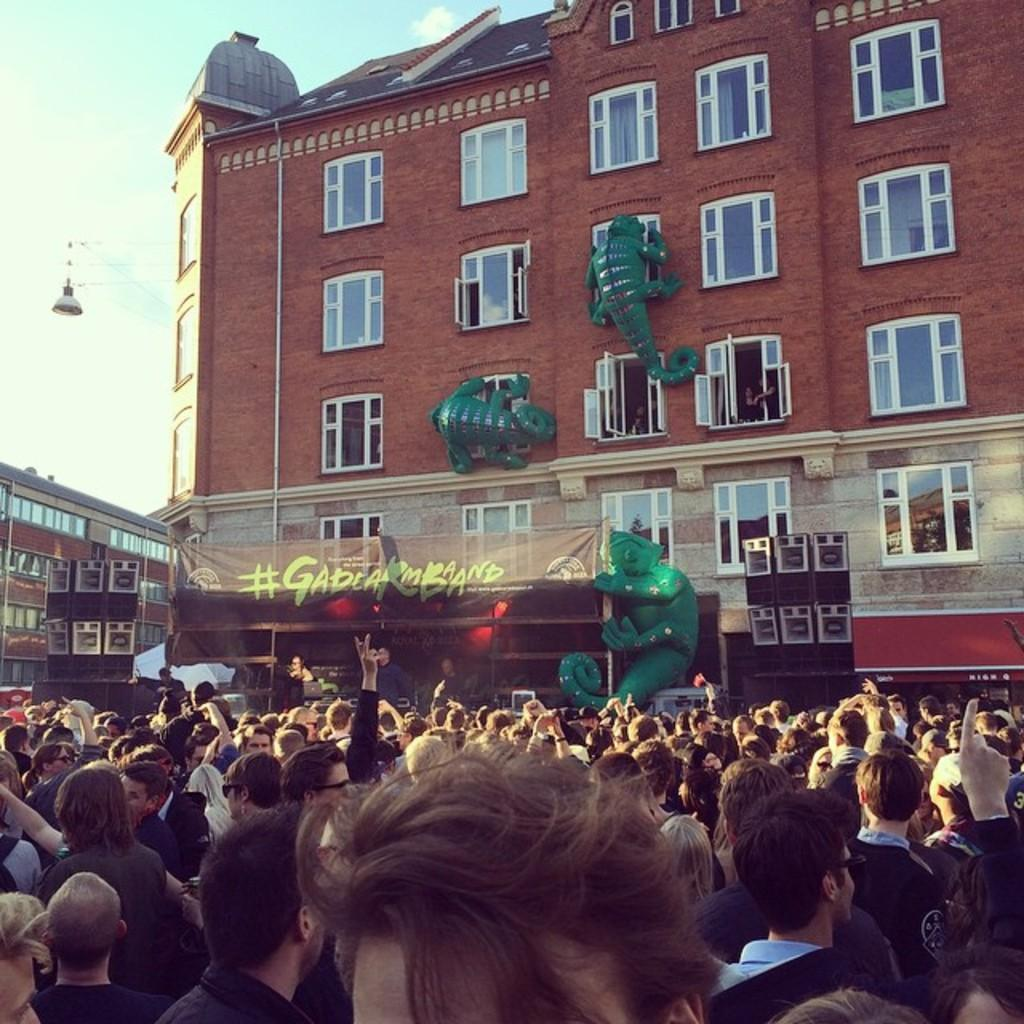What type of structures can be seen in the image? There are buildings in the image. What else can be seen in the image besides the buildings? Cables, street lights, speakers, advertisements, and the sky are visible in the image. Can you describe the describe the sky in the image? The sky is visible in the image, and clouds are present. What is the position of the persons in the image? Persons are standing on the road in the image. What type of adjustment can be seen being made to the money in the image? There is no money present in the image, so no adjustment can be observed. What type of offer is being made by the person in the image? There are no persons making offers in the image; the only persons present are standing on the road. 